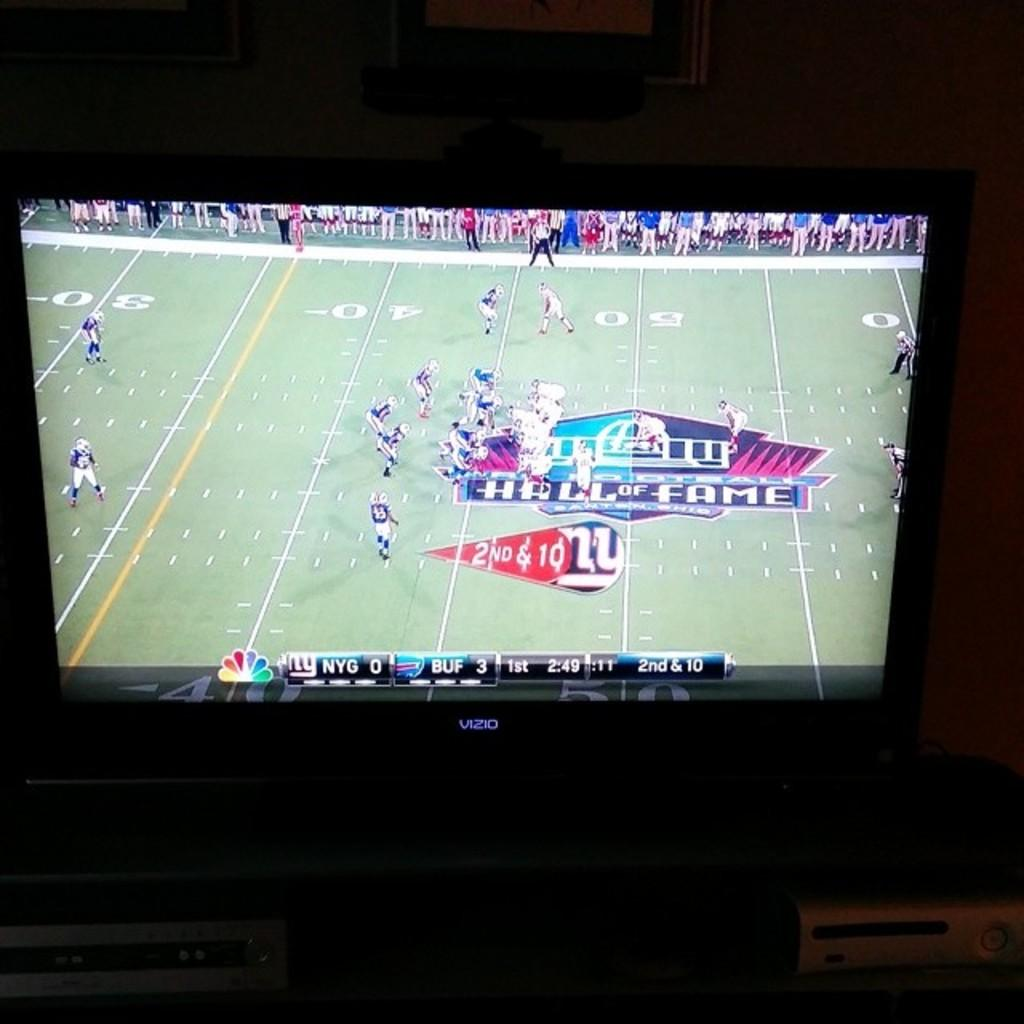Provide a one-sentence caption for the provided image. tv screen showing nfl game between new york giants and buffalo bills. 